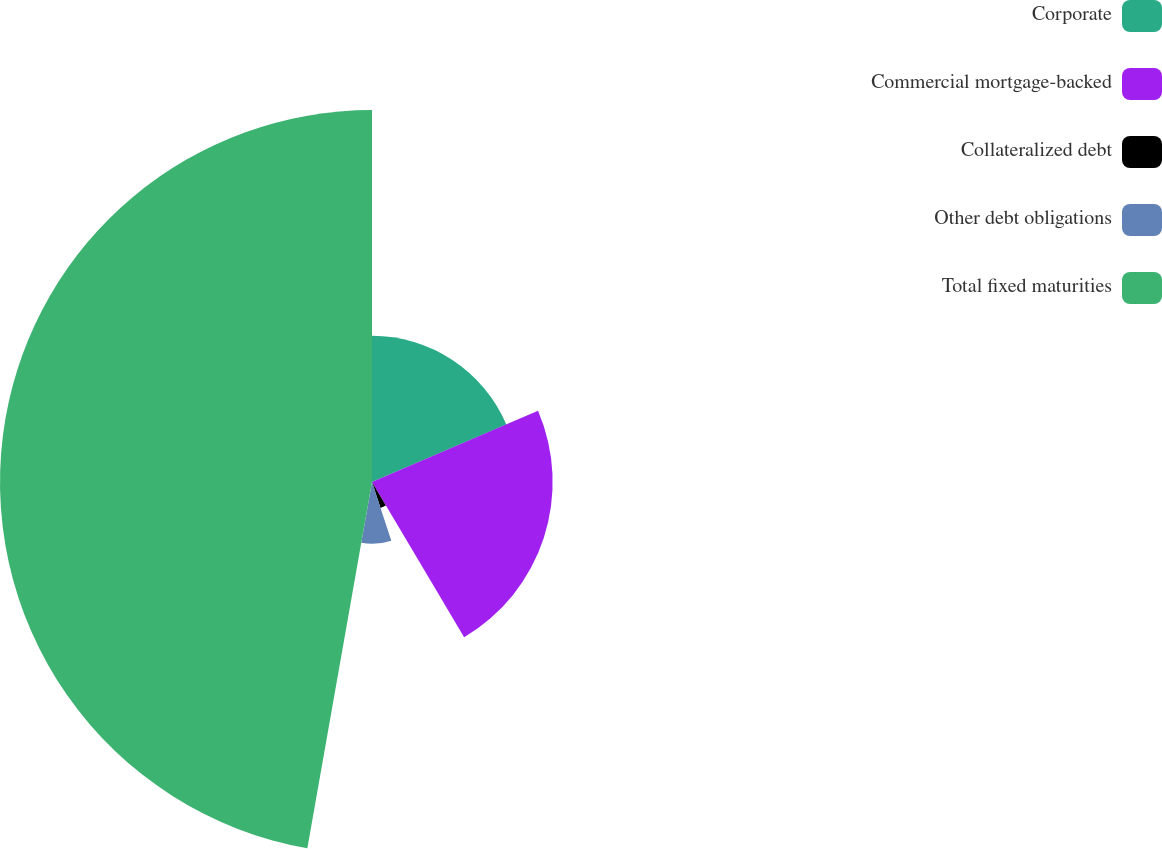Convert chart. <chart><loc_0><loc_0><loc_500><loc_500><pie_chart><fcel>Corporate<fcel>Commercial mortgage-backed<fcel>Collateralized debt<fcel>Other debt obligations<fcel>Total fixed maturities<nl><fcel>18.55%<fcel>22.93%<fcel>3.46%<fcel>7.84%<fcel>47.22%<nl></chart> 